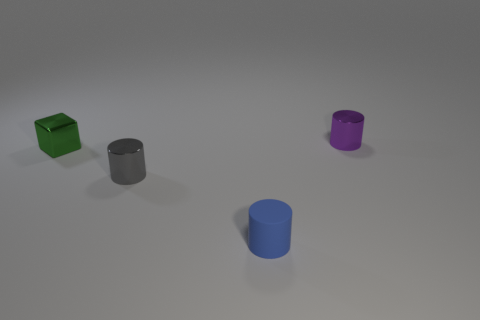Is the cube the same color as the matte thing?
Ensure brevity in your answer.  No. There is a metal thing in front of the green cube; is it the same shape as the blue thing?
Give a very brief answer. Yes. What number of other objects are the same shape as the rubber object?
Provide a succinct answer. 2. There is a thing that is in front of the tiny gray object; what is its shape?
Your answer should be very brief. Cylinder. Are there any tiny blocks that have the same material as the small purple thing?
Offer a very short reply. Yes. Is the color of the thing that is behind the green shiny object the same as the rubber cylinder?
Keep it short and to the point. No. What is the size of the rubber object?
Make the answer very short. Small. Are there any small green metal blocks behind the metallic object that is right of the metal cylinder that is in front of the tiny metallic block?
Ensure brevity in your answer.  No. There is a small gray metallic cylinder; what number of tiny matte objects are right of it?
Keep it short and to the point. 1. What number of small rubber objects are the same color as the rubber cylinder?
Your response must be concise. 0. 